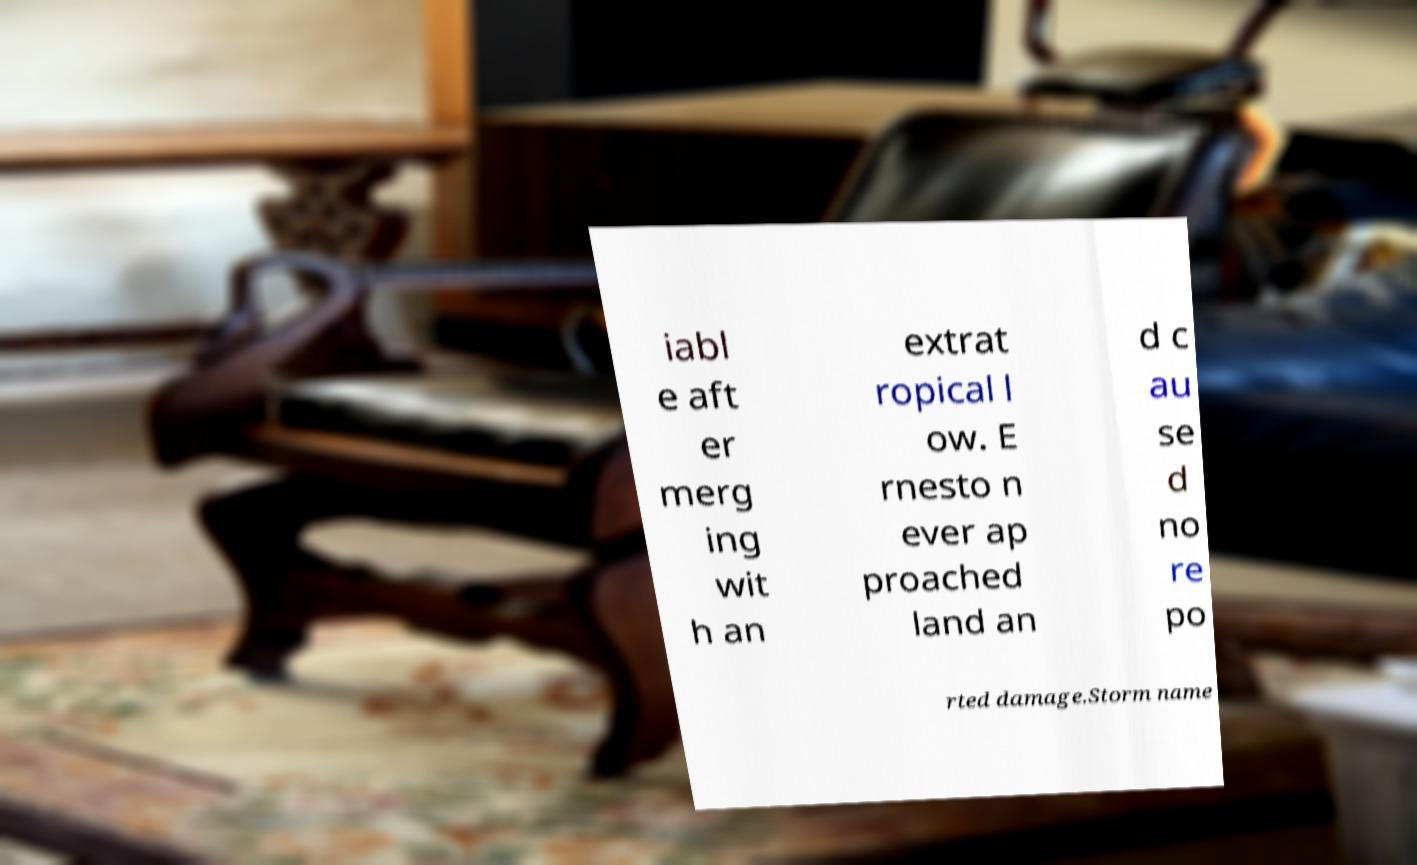Can you accurately transcribe the text from the provided image for me? iabl e aft er merg ing wit h an extrat ropical l ow. E rnesto n ever ap proached land an d c au se d no re po rted damage.Storm name 